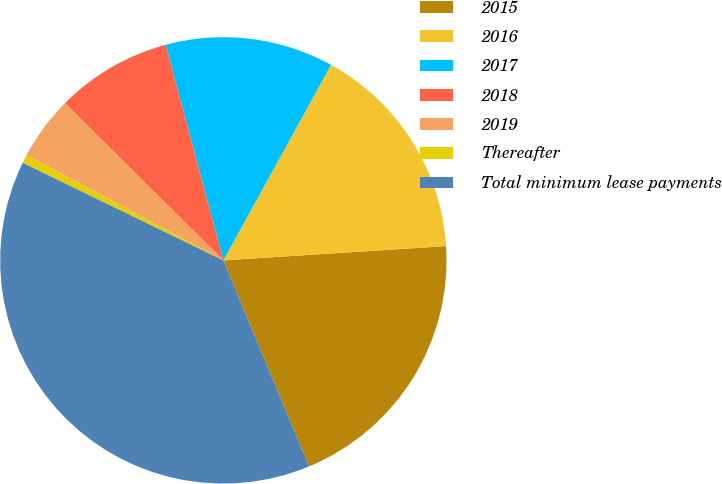Convert chart to OTSL. <chart><loc_0><loc_0><loc_500><loc_500><pie_chart><fcel>2015<fcel>2016<fcel>2017<fcel>2018<fcel>2019<fcel>Thereafter<fcel>Total minimum lease payments<nl><fcel>19.75%<fcel>15.97%<fcel>12.18%<fcel>8.4%<fcel>4.61%<fcel>0.62%<fcel>38.47%<nl></chart> 